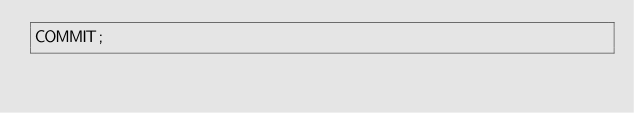<code> <loc_0><loc_0><loc_500><loc_500><_SQL_>COMMIT;
</code> 